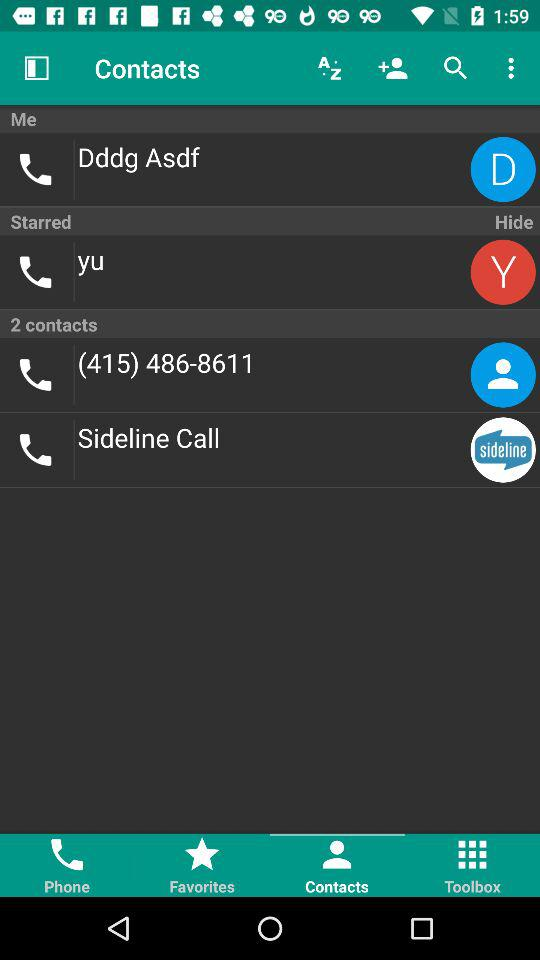How many contacts are in the contact list? There are 2 contacts in the contact list. 